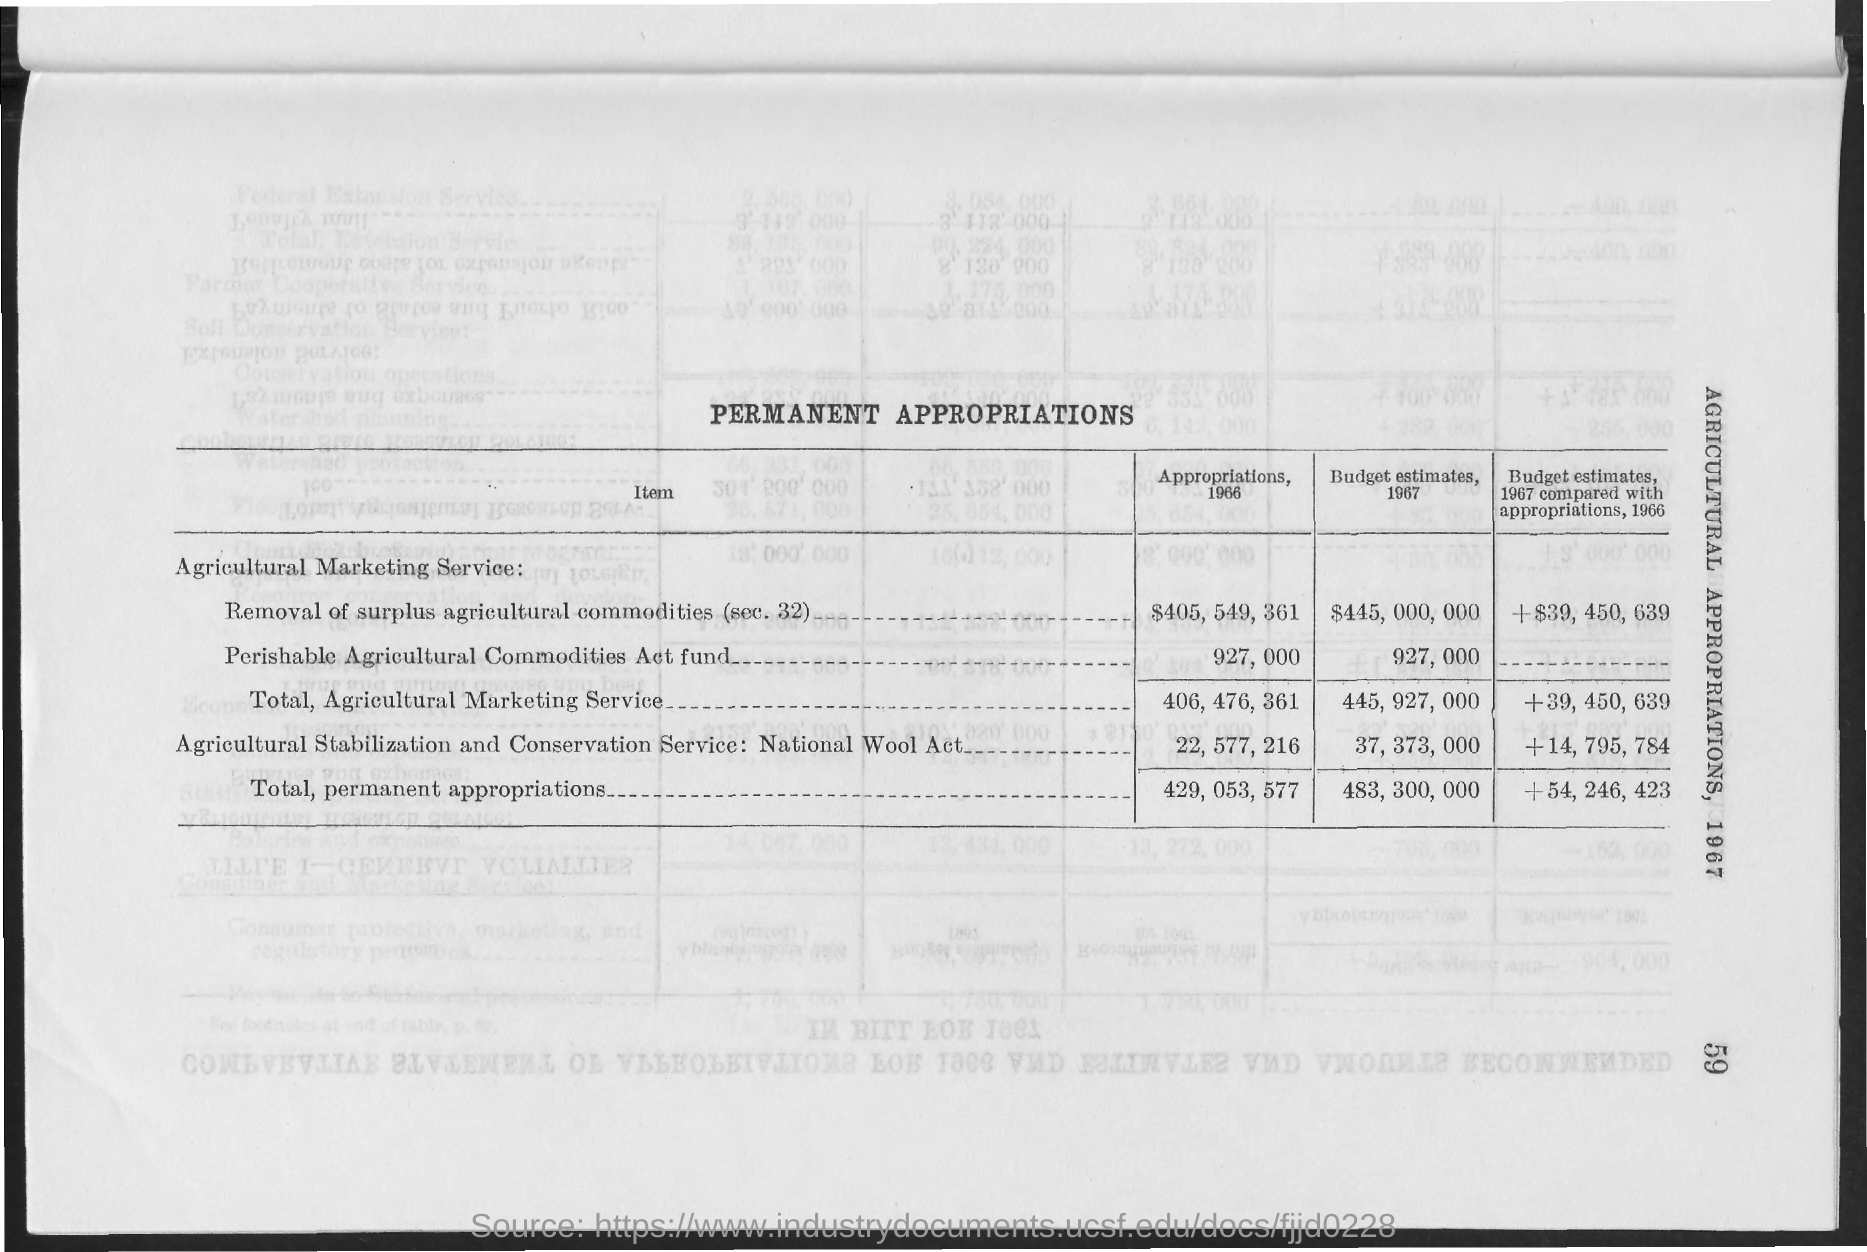Mention a couple of crucial points in this snapshot. The first column heading of the table is "Item... The heading of the table is "PERMANENT APPROPRIATIONS. 